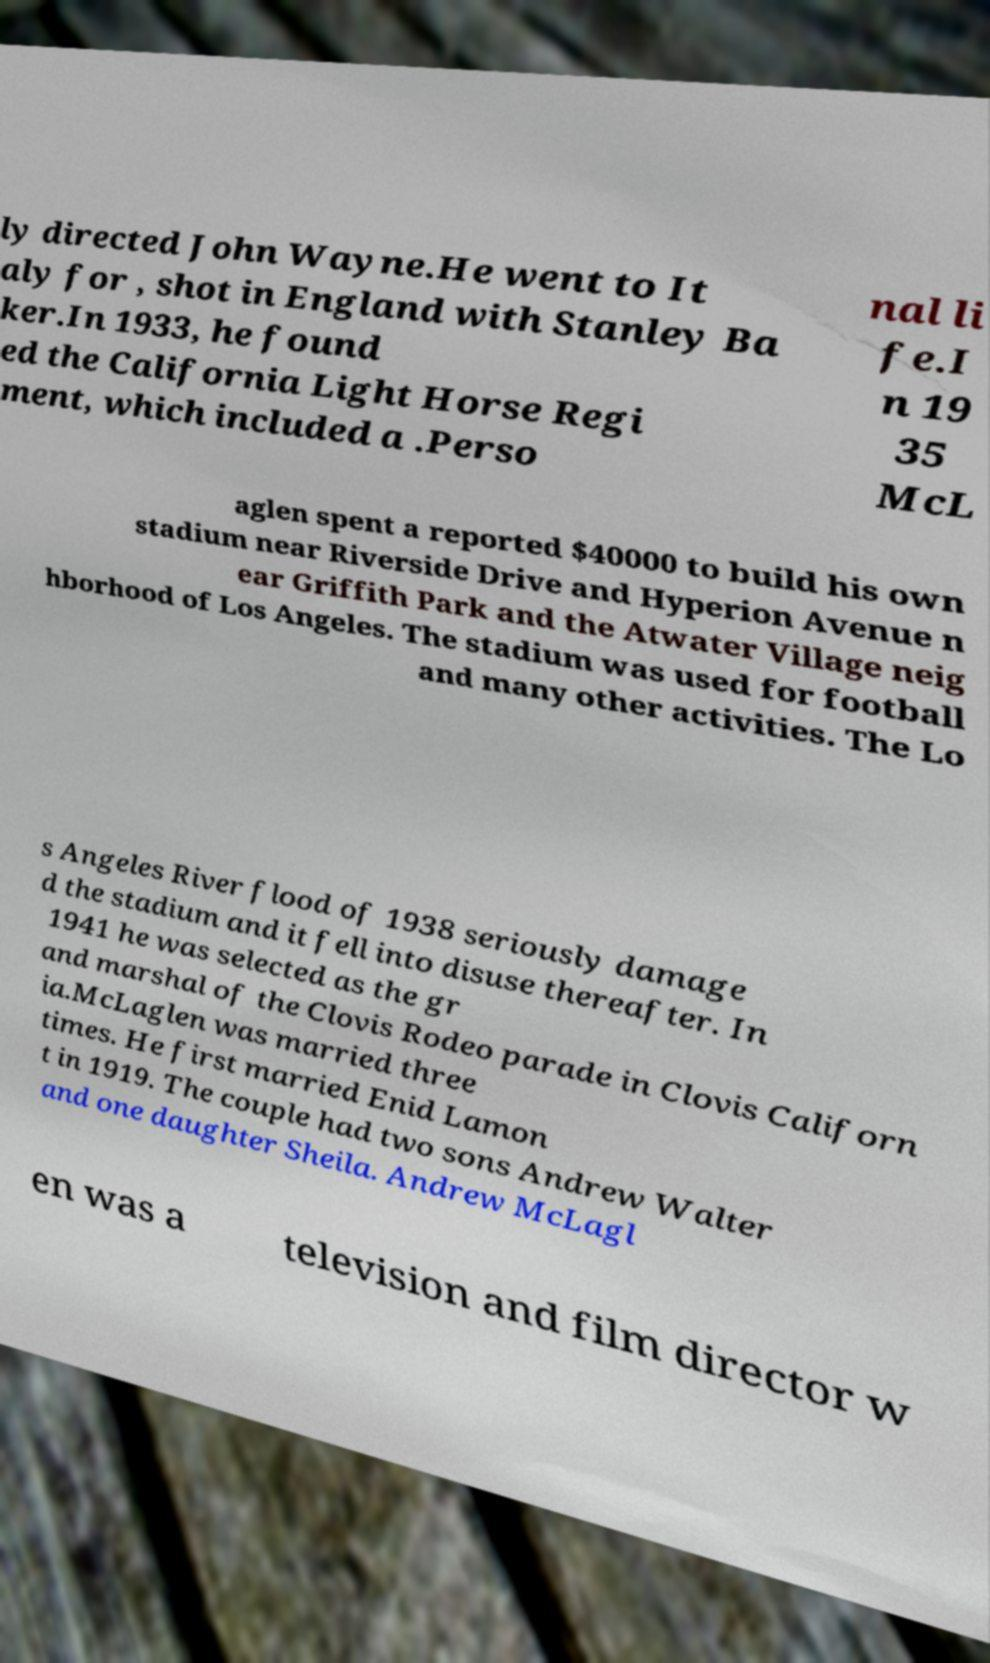Please read and relay the text visible in this image. What does it say? ly directed John Wayne.He went to It aly for , shot in England with Stanley Ba ker.In 1933, he found ed the California Light Horse Regi ment, which included a .Perso nal li fe.I n 19 35 McL aglen spent a reported $40000 to build his own stadium near Riverside Drive and Hyperion Avenue n ear Griffith Park and the Atwater Village neig hborhood of Los Angeles. The stadium was used for football and many other activities. The Lo s Angeles River flood of 1938 seriously damage d the stadium and it fell into disuse thereafter. In 1941 he was selected as the gr and marshal of the Clovis Rodeo parade in Clovis Californ ia.McLaglen was married three times. He first married Enid Lamon t in 1919. The couple had two sons Andrew Walter and one daughter Sheila. Andrew McLagl en was a television and film director w 